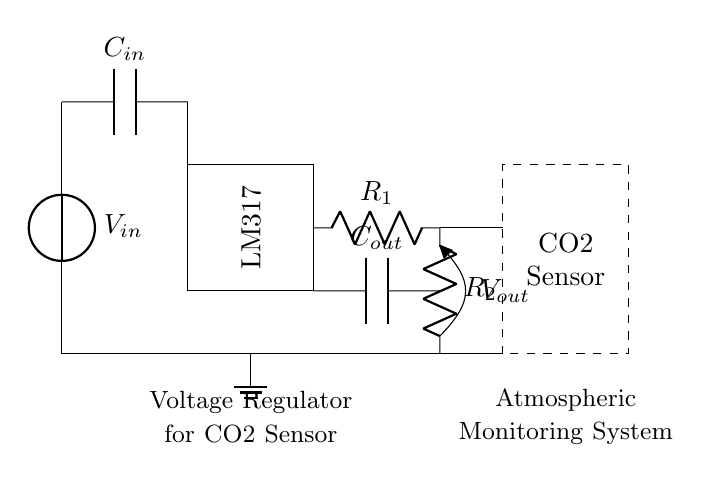What is the input voltage source in the circuit? The input voltage source is labeled as V_in, which represents the voltage supplied to the circuit.
Answer: V_in What is the role of the LM317 in this circuit? The LM317 is a voltage regulator integrated circuit that maintains a constant output voltage despite variations in input voltage or output load.
Answer: Voltage regulator What are the two resistors in the circuit? The resistors R1 and R2 are used in conjunction with the LM317 to set the output voltage.
Answer: R1 and R2 How many capacitors are present in the circuit? There are two capacitors, C_in and C_out, which are used for filtering and stability in the regulation process.
Answer: Two What is the expected output voltage from the regulator? The output voltage is determined by the values of R1 and R2, which set the voltage drop across the LM317; it is not directly labeled in the circuit.
Answer: V_out Why is grounding important in this circuit? Grounding provides a common reference point for the voltage levels in the circuit, ensuring the stability and functionality of the voltage regulator and connected components.
Answer: Stability What component is used as a load for the regulator? The load connected to the voltage regulator in this circuit is the CO2 sensor that requires a specific operating voltage.
Answer: CO2 sensor 